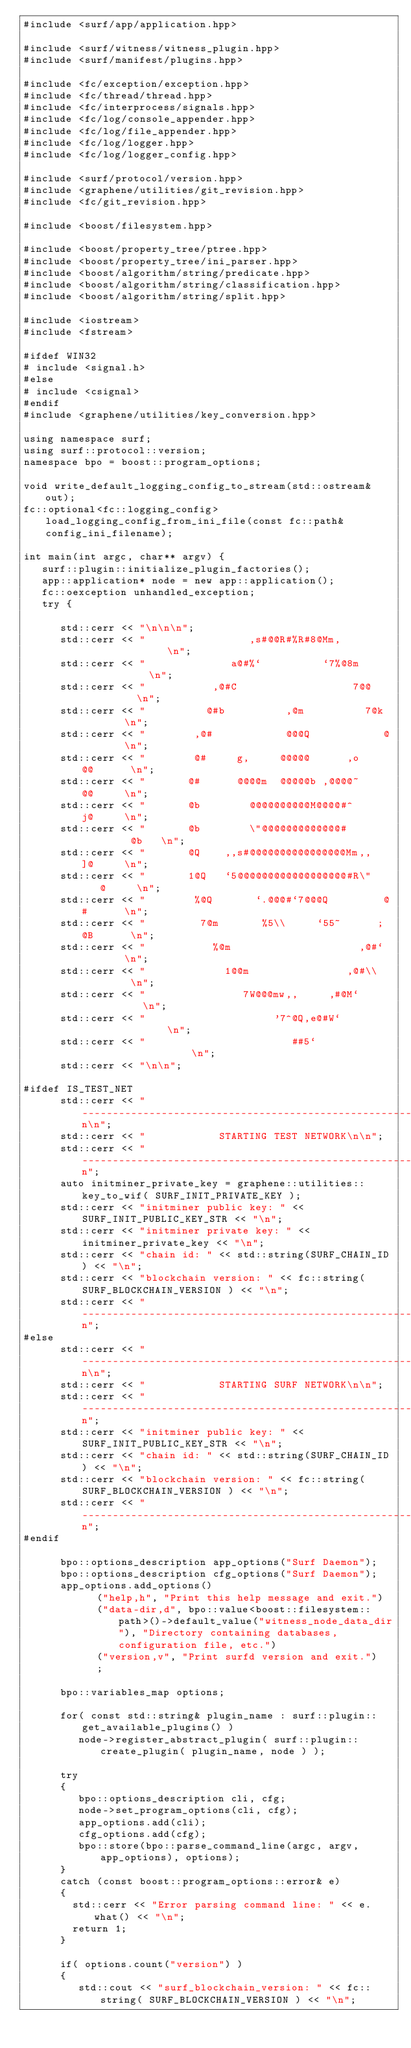Convert code to text. <code><loc_0><loc_0><loc_500><loc_500><_C++_>#include <surf/app/application.hpp>

#include <surf/witness/witness_plugin.hpp>
#include <surf/manifest/plugins.hpp>

#include <fc/exception/exception.hpp>
#include <fc/thread/thread.hpp>
#include <fc/interprocess/signals.hpp>
#include <fc/log/console_appender.hpp>
#include <fc/log/file_appender.hpp>
#include <fc/log/logger.hpp>
#include <fc/log/logger_config.hpp>

#include <surf/protocol/version.hpp>
#include <graphene/utilities/git_revision.hpp>
#include <fc/git_revision.hpp>

#include <boost/filesystem.hpp>

#include <boost/property_tree/ptree.hpp>
#include <boost/property_tree/ini_parser.hpp>
#include <boost/algorithm/string/predicate.hpp>
#include <boost/algorithm/string/classification.hpp>
#include <boost/algorithm/string/split.hpp>

#include <iostream>
#include <fstream>

#ifdef WIN32
# include <signal.h>
#else
# include <csignal>
#endif
#include <graphene/utilities/key_conversion.hpp>

using namespace surf;
using surf::protocol::version;
namespace bpo = boost::program_options;

void write_default_logging_config_to_stream(std::ostream& out);
fc::optional<fc::logging_config> load_logging_config_from_ini_file(const fc::path& config_ini_filename);

int main(int argc, char** argv) {
   surf::plugin::initialize_plugin_factories();
   app::application* node = new app::application();
   fc::oexception unhandled_exception;
   try {

      std::cerr << "\n\n\n";
      std::cerr << "                 ,s#@@R#%R#8@Mm,               \n";
      std::cerr << "              a@#%`          `7%@8m            \n";
      std::cerr << "           ,@#C                   7@@          \n";
      std::cerr << "          @#b          ,@m          7@k        \n";
      std::cerr << "        ,@#            @@@Q            @       \n";
      std::cerr << "        @#     g,     @@@@@      ,o    @@      \n";
      std::cerr << "       @#      @@@@m  @@@@@b ,@@@@~     @@     \n";
      std::cerr << "       @b        @@@@@@@@@@M@@@@#^      j@     \n";
      std::cerr << "       @b        \"@@@@@@@@@@@@@#         @b   \n";
      std::cerr << "       @Q    ,,s#@@@@@@@@@@@@@@@@Mm,,   ]@     \n";
      std::cerr << "       1@Q   `5@@@@@@@@@@@@@@@@@@#R\"    @     \n";
      std::cerr << "        %@Q       `.@@@#`7@@@Q         @#      \n";
      std::cerr << "         7@m       %5\\     `55~      ;@B      \n";
      std::cerr << "           %@m                     ,@#`        \n";
      std::cerr << "             1@@m                ,@#\\         \n";
      std::cerr << "                7W@@@mw,,     ,#@M`           \n";
      std::cerr << "                     '7^@Q,e@#W`               \n";
      std::cerr << "                        ##5`                   \n";
      std::cerr << "\n\n";

#ifdef IS_TEST_NET
      std::cerr << "------------------------------------------------------\n\n";
      std::cerr << "            STARTING TEST NETWORK\n\n";
      std::cerr << "------------------------------------------------------\n";
      auto initminer_private_key = graphene::utilities::key_to_wif( SURF_INIT_PRIVATE_KEY );
      std::cerr << "initminer public key: " << SURF_INIT_PUBLIC_KEY_STR << "\n";
      std::cerr << "initminer private key: " << initminer_private_key << "\n";
      std::cerr << "chain id: " << std::string(SURF_CHAIN_ID) << "\n";
      std::cerr << "blockchain version: " << fc::string( SURF_BLOCKCHAIN_VERSION ) << "\n";
      std::cerr << "------------------------------------------------------\n";
#else
      std::cerr << "------------------------------------------------------\n\n";
      std::cerr << "            STARTING SURF NETWORK\n\n";
      std::cerr << "------------------------------------------------------\n";
      std::cerr << "initminer public key: " << SURF_INIT_PUBLIC_KEY_STR << "\n";
      std::cerr << "chain id: " << std::string(SURF_CHAIN_ID) << "\n";
      std::cerr << "blockchain version: " << fc::string( SURF_BLOCKCHAIN_VERSION ) << "\n";
      std::cerr << "------------------------------------------------------\n";
#endif

      bpo::options_description app_options("Surf Daemon");
      bpo::options_description cfg_options("Surf Daemon");
      app_options.add_options()
            ("help,h", "Print this help message and exit.")
            ("data-dir,d", bpo::value<boost::filesystem::path>()->default_value("witness_node_data_dir"), "Directory containing databases, configuration file, etc.")
            ("version,v", "Print surfd version and exit.")
            ;

      bpo::variables_map options;

      for( const std::string& plugin_name : surf::plugin::get_available_plugins() )
         node->register_abstract_plugin( surf::plugin::create_plugin( plugin_name, node ) );

      try
      {
         bpo::options_description cli, cfg;
         node->set_program_options(cli, cfg);
         app_options.add(cli);
         cfg_options.add(cfg);
         bpo::store(bpo::parse_command_line(argc, argv, app_options), options);
      }
      catch (const boost::program_options::error& e)
      {
        std::cerr << "Error parsing command line: " << e.what() << "\n";
        return 1;
      }

      if( options.count("version") )
      {
         std::cout << "surf_blockchain_version: " << fc::string( SURF_BLOCKCHAIN_VERSION ) << "\n";</code> 